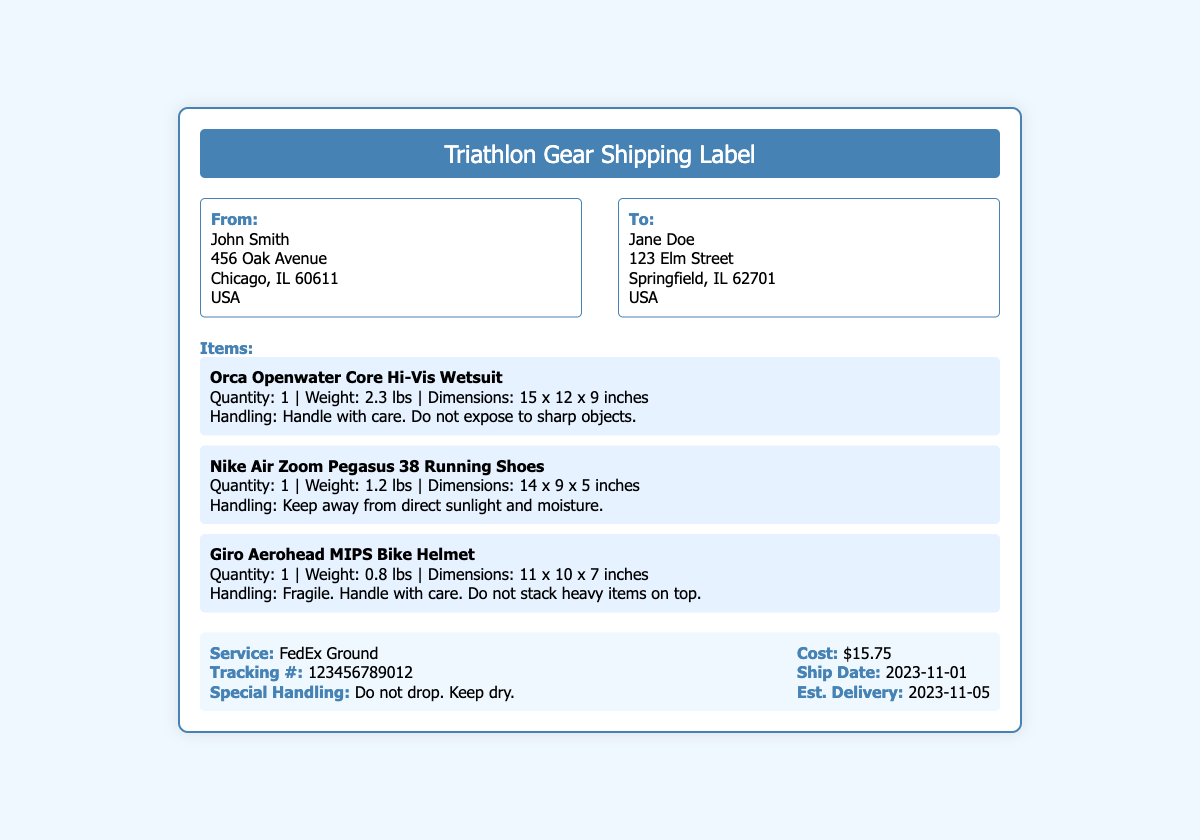What items are being shipped? The items listed in the document include a wetsuit, running shoes, and a bike helmet.
Answer: Orca Openwater Core Hi-Vis Wetsuit, Nike Air Zoom Pegasus 38 Running Shoes, Giro Aerohead MIPS Bike Helmet What is the shipping cost? The shipping cost is stated clearly in the shipping information section of the document.
Answer: $15.75 What is the weight of the wetsuit? The weight of the wetsuit is specifically mentioned in the item's description.
Answer: 2.3 lbs When is the estimated delivery date? The estimated delivery date is found in the shipping information section of the document.
Answer: 2023-11-05 Who is the recipient of the package? The document provides the name and address of the recipient.
Answer: Jane Doe What is the special handling instruction for the bike helmet? The handling instruction for the bike helmet is mentioned in its description section.
Answer: Fragile. Handle with care. Do not stack heavy items on top What is the tracking number for this shipment? The tracking number is listed in the shipping information section of the document.
Answer: 123456789012 What delivery service is used for shipping? The delivery service is stated clearly in the shipping information section of the document.
Answer: FedEx Ground What is the quantity of the running shoes? The quantity of the running shoes is specified in the item's description.
Answer: 1 